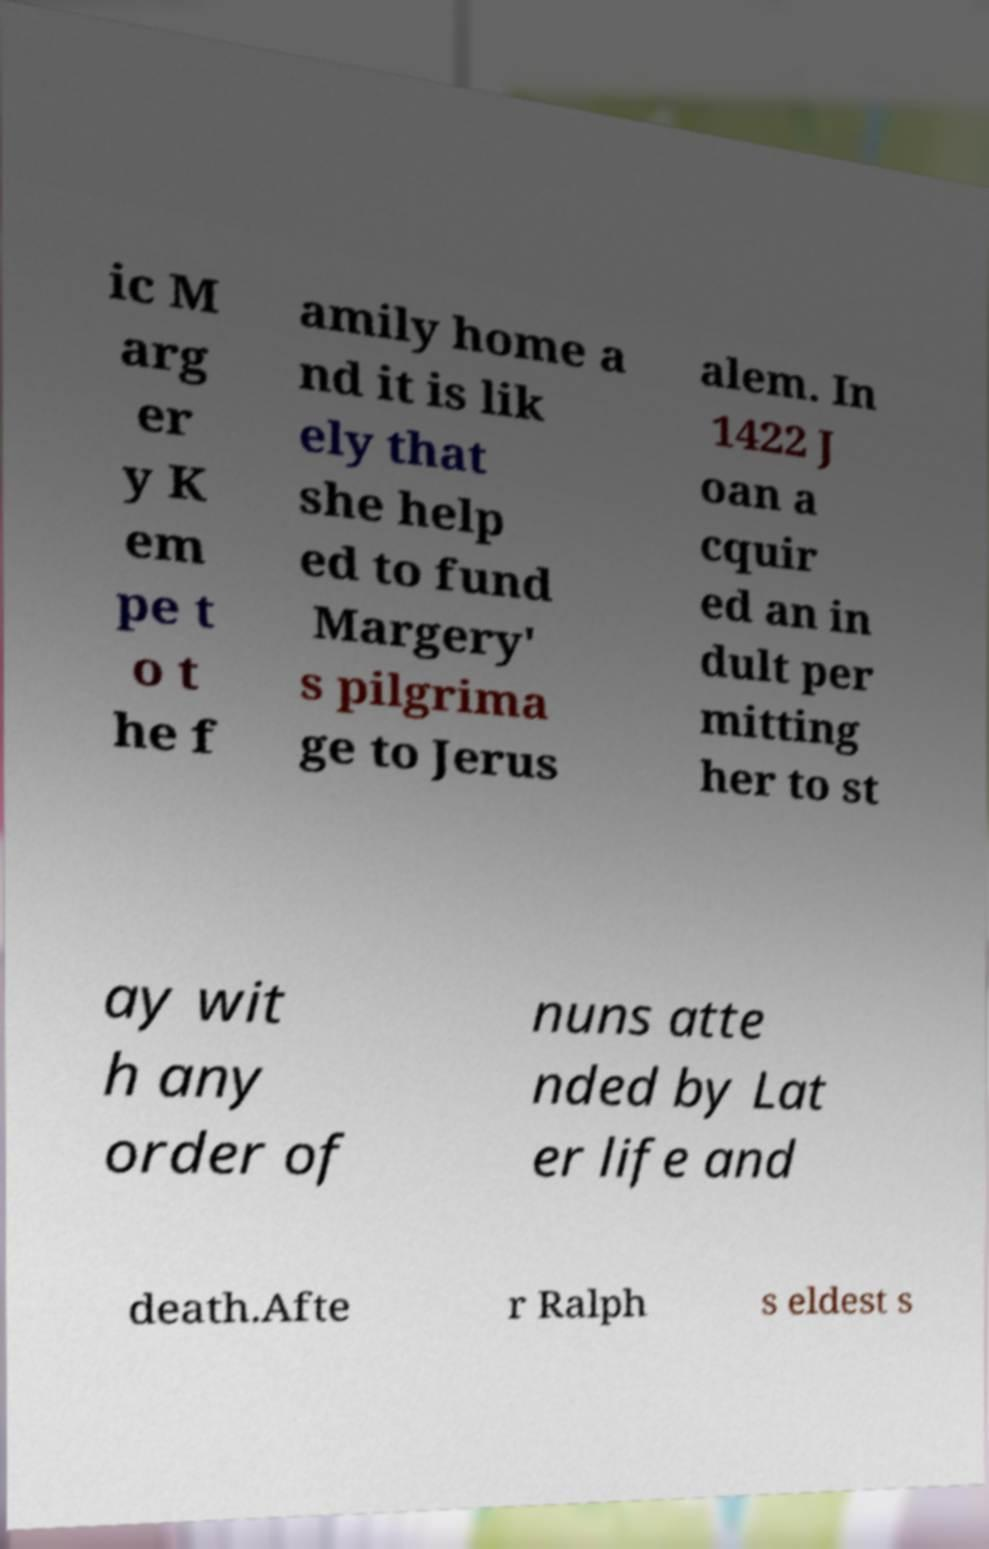Can you read and provide the text displayed in the image?This photo seems to have some interesting text. Can you extract and type it out for me? ic M arg er y K em pe t o t he f amily home a nd it is lik ely that she help ed to fund Margery' s pilgrima ge to Jerus alem. In 1422 J oan a cquir ed an in dult per mitting her to st ay wit h any order of nuns atte nded by Lat er life and death.Afte r Ralph s eldest s 